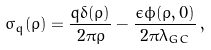Convert formula to latex. <formula><loc_0><loc_0><loc_500><loc_500>\sigma _ { q } ( \varrho ) = \frac { q \delta ( \varrho ) } { 2 \pi \varrho } - \frac { \epsilon \phi ( \varrho , 0 ) } { 2 \pi \lambda _ { G C } } \, ,</formula> 